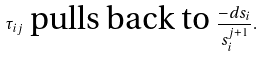<formula> <loc_0><loc_0><loc_500><loc_500>\tau _ { i j } \ \text {pulls back to} \ \frac { - d s _ { i } } { s _ { i } ^ { j + 1 } } .</formula> 